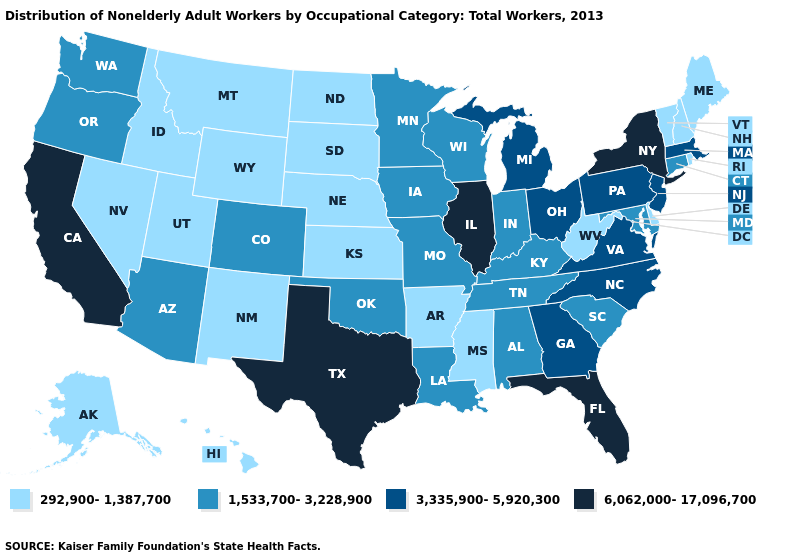Name the states that have a value in the range 292,900-1,387,700?
Concise answer only. Alaska, Arkansas, Delaware, Hawaii, Idaho, Kansas, Maine, Mississippi, Montana, Nebraska, Nevada, New Hampshire, New Mexico, North Dakota, Rhode Island, South Dakota, Utah, Vermont, West Virginia, Wyoming. What is the lowest value in the USA?
Quick response, please. 292,900-1,387,700. What is the lowest value in the West?
Give a very brief answer. 292,900-1,387,700. What is the lowest value in states that border New Jersey?
Quick response, please. 292,900-1,387,700. Which states have the highest value in the USA?
Be succinct. California, Florida, Illinois, New York, Texas. What is the value of Iowa?
Short answer required. 1,533,700-3,228,900. Which states have the lowest value in the South?
Short answer required. Arkansas, Delaware, Mississippi, West Virginia. Does Texas have the highest value in the South?
Answer briefly. Yes. What is the value of Wyoming?
Answer briefly. 292,900-1,387,700. What is the value of Texas?
Quick response, please. 6,062,000-17,096,700. Does Oregon have the lowest value in the USA?
Answer briefly. No. What is the value of Hawaii?
Quick response, please. 292,900-1,387,700. Name the states that have a value in the range 6,062,000-17,096,700?
Answer briefly. California, Florida, Illinois, New York, Texas. Which states have the lowest value in the Northeast?
Be succinct. Maine, New Hampshire, Rhode Island, Vermont. What is the value of Arkansas?
Short answer required. 292,900-1,387,700. 